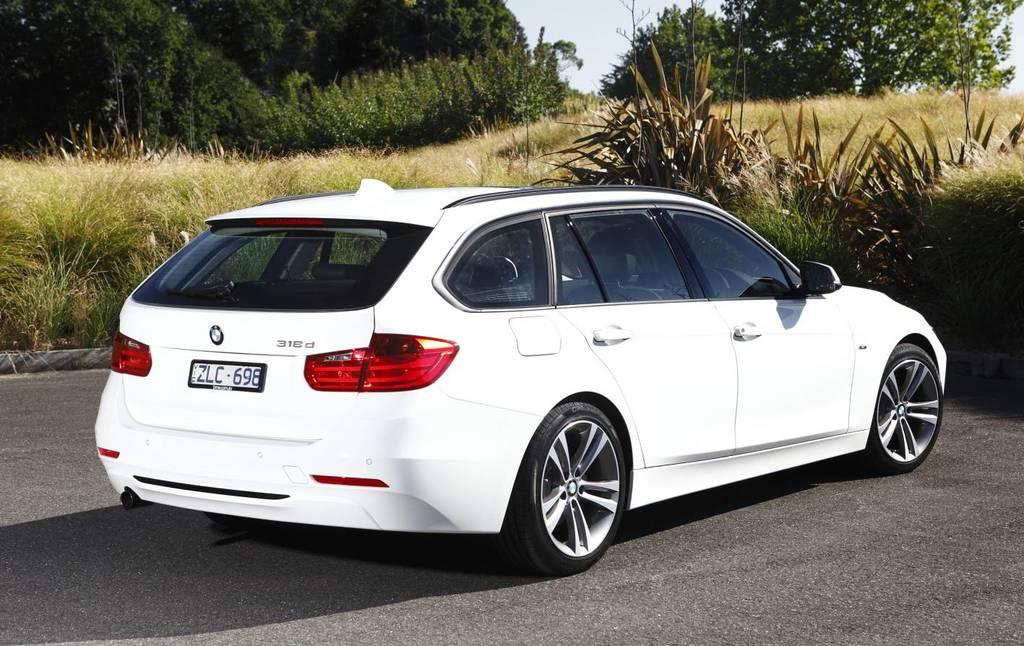<image>
Describe the image concisely. A white BMW with license plate, ZLC - 698, parked near a brushy area on the side of a street. 